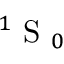Convert formula to latex. <formula><loc_0><loc_0><loc_500><loc_500>^ { 1 } S _ { 0 }</formula> 